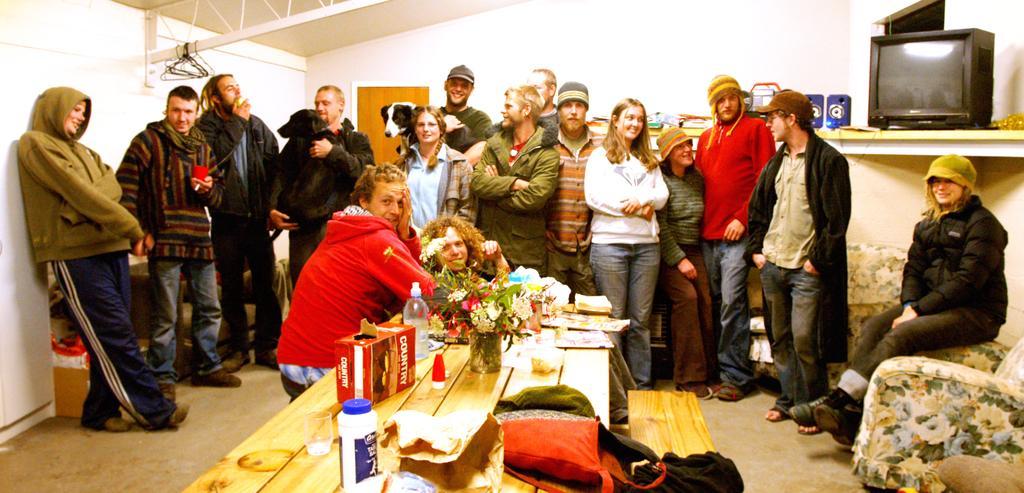Describe this image in one or two sentences. In the center of the image there is a table on which there are objects. In the background of the image there are people standing. There is wall. To the right side of the image there is a tv. There is a chair. 